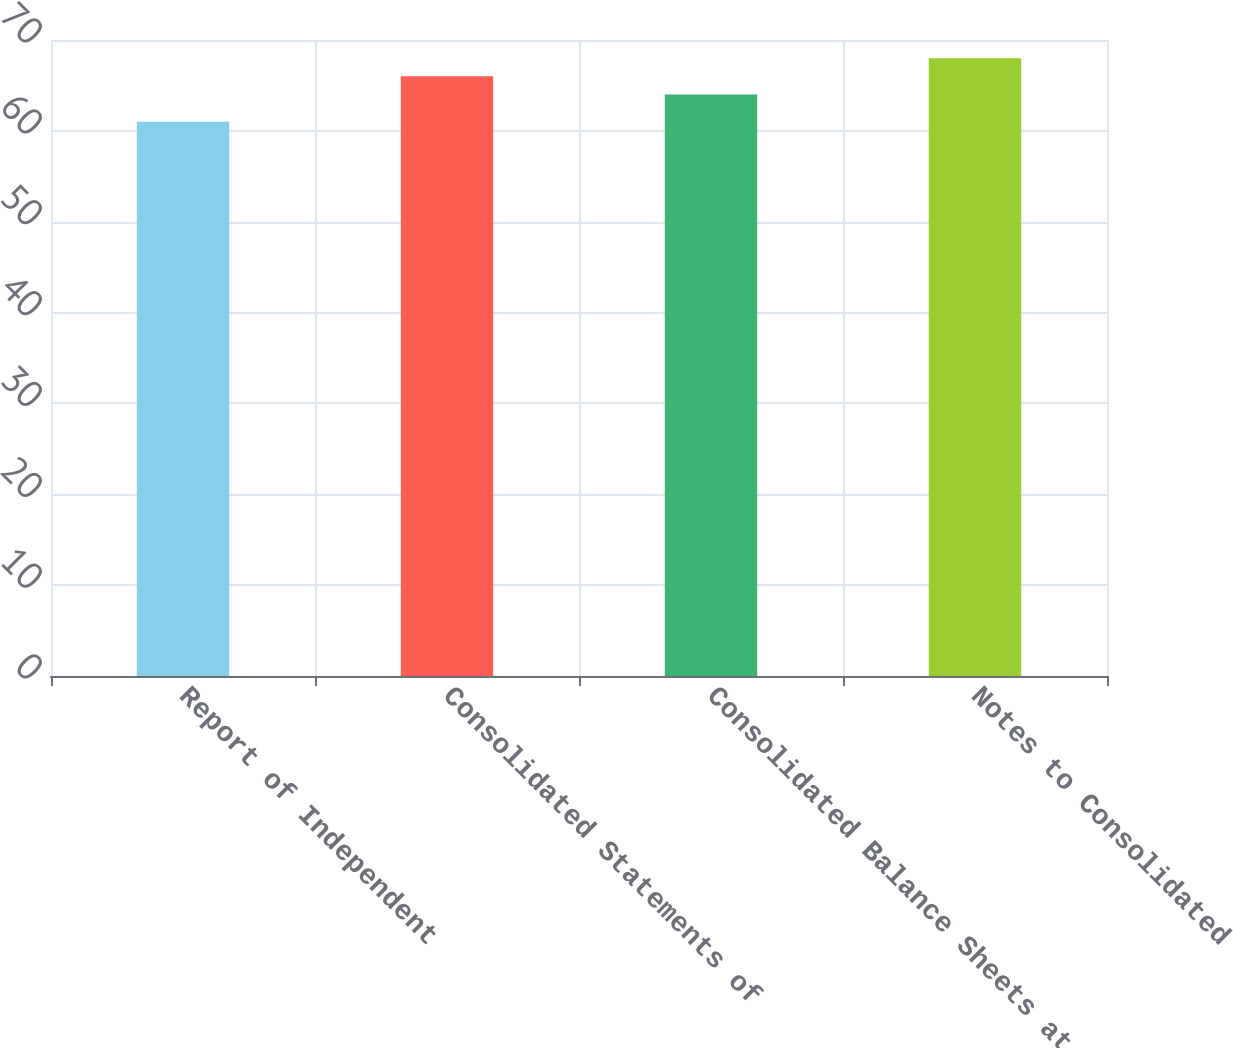<chart> <loc_0><loc_0><loc_500><loc_500><bar_chart><fcel>Report of Independent<fcel>Consolidated Statements of<fcel>Consolidated Balance Sheets at<fcel>Notes to Consolidated<nl><fcel>61<fcel>66<fcel>64<fcel>68<nl></chart> 